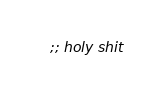<code> <loc_0><loc_0><loc_500><loc_500><_Scheme_>;; holy shit
</code> 